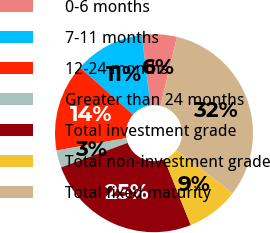Convert chart to OTSL. <chart><loc_0><loc_0><loc_500><loc_500><pie_chart><fcel>0-6 months<fcel>7-11 months<fcel>12-24 months<fcel>Greater than 24 months<fcel>Total investment grade<fcel>Total non-investment grade<fcel>Total fixed maturity<nl><fcel>5.71%<fcel>11.47%<fcel>14.35%<fcel>2.82%<fcel>25.44%<fcel>8.59%<fcel>31.63%<nl></chart> 